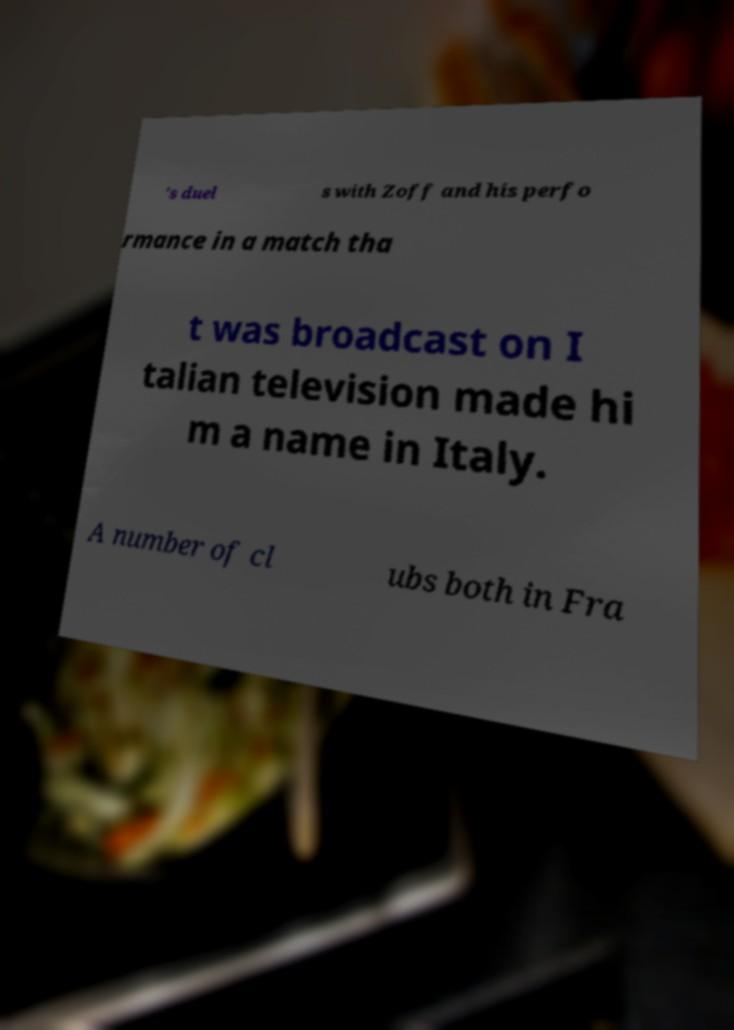For documentation purposes, I need the text within this image transcribed. Could you provide that? 's duel s with Zoff and his perfo rmance in a match tha t was broadcast on I talian television made hi m a name in Italy. A number of cl ubs both in Fra 